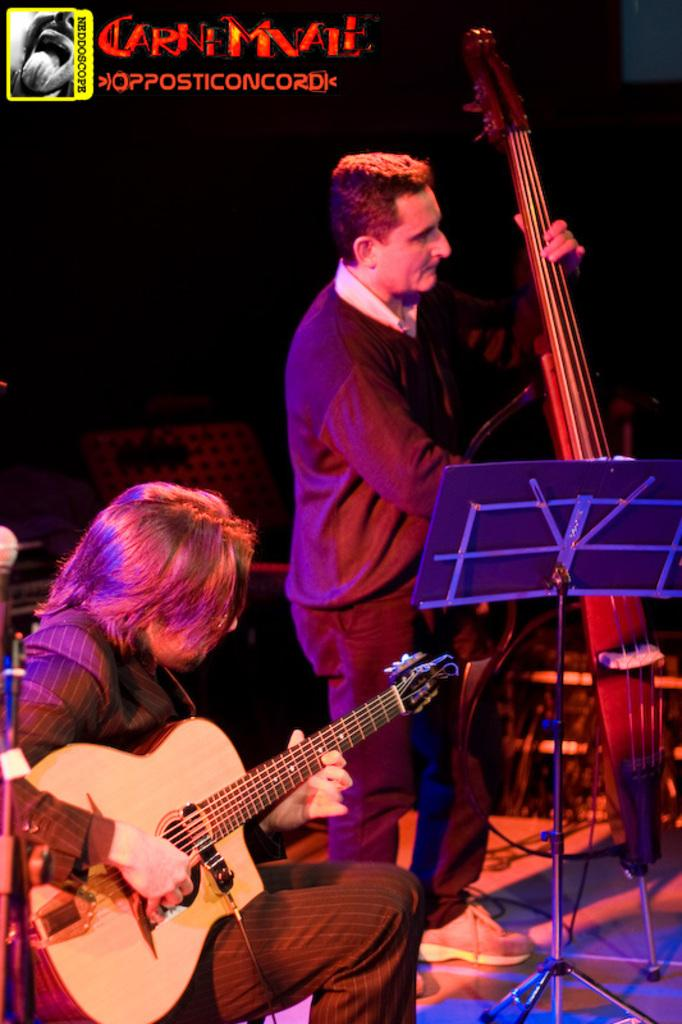What is the man in the image doing? The man is sitting and playing a guitar. Can you describe the other person in the image? There is another man standing in the image, and he is playing a cello. What disease is the man playing the guitar trying to cure in the image? There is no indication of a disease or any medical context in the image. The man is simply playing a guitar. 